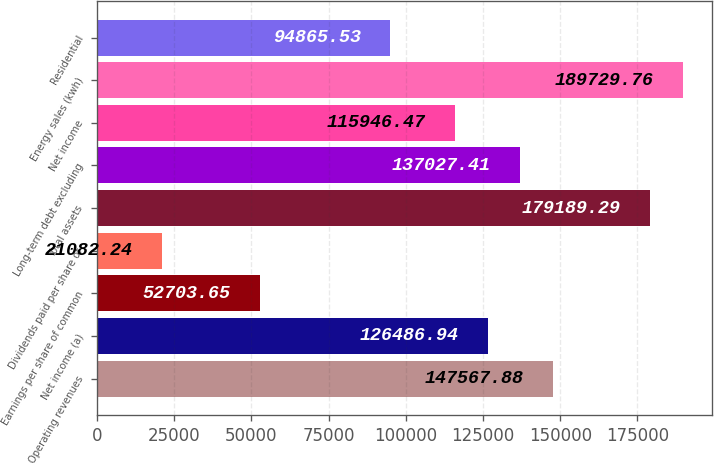<chart> <loc_0><loc_0><loc_500><loc_500><bar_chart><fcel>Operating revenues<fcel>Net income (a)<fcel>Earnings per share of common<fcel>Dividends paid per share of<fcel>Total assets<fcel>Long-term debt excluding<fcel>Net income<fcel>Energy sales (kwh)<fcel>Residential<nl><fcel>147568<fcel>126487<fcel>52703.7<fcel>21082.2<fcel>179189<fcel>137027<fcel>115946<fcel>189730<fcel>94865.5<nl></chart> 